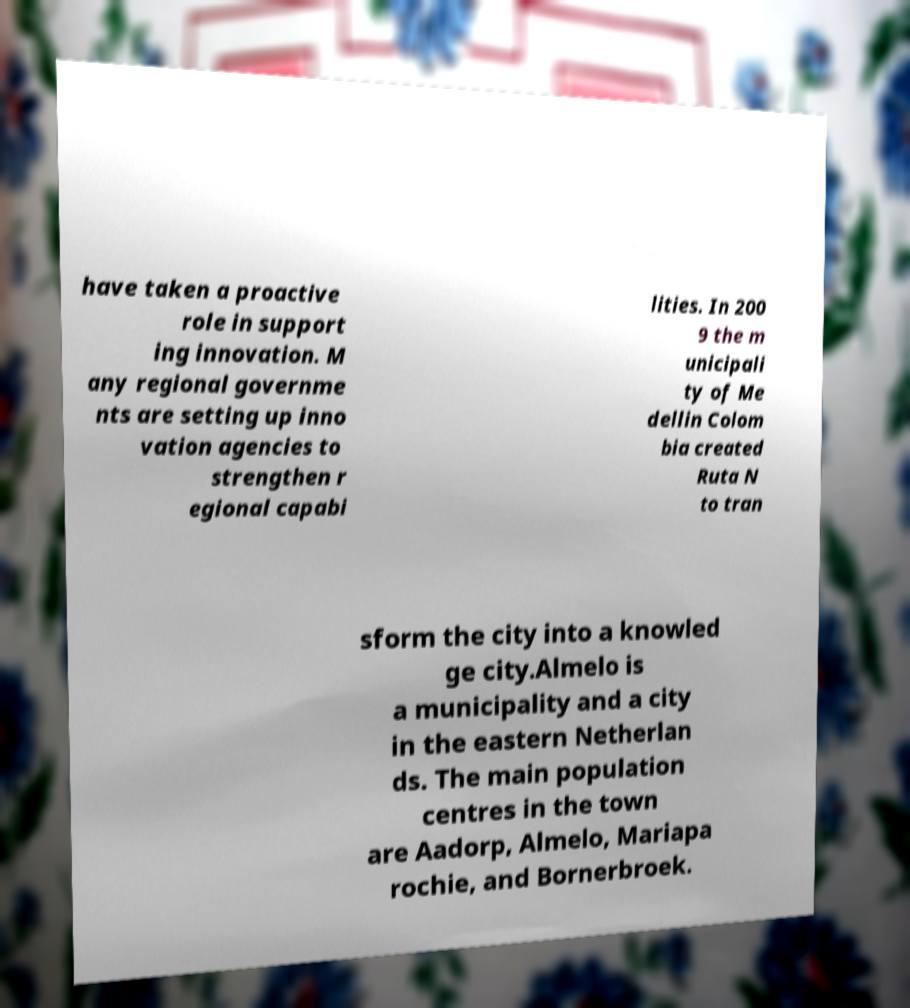What messages or text are displayed in this image? I need them in a readable, typed format. have taken a proactive role in support ing innovation. M any regional governme nts are setting up inno vation agencies to strengthen r egional capabi lities. In 200 9 the m unicipali ty of Me dellin Colom bia created Ruta N to tran sform the city into a knowled ge city.Almelo is a municipality and a city in the eastern Netherlan ds. The main population centres in the town are Aadorp, Almelo, Mariapa rochie, and Bornerbroek. 